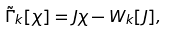<formula> <loc_0><loc_0><loc_500><loc_500>\tilde { \Gamma } _ { k } [ \chi ] = J \chi - W _ { k } [ J ] ,</formula> 